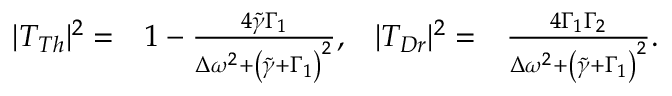Convert formula to latex. <formula><loc_0><loc_0><loc_500><loc_500>\begin{array} { r l r l } { | T _ { T h } | ^ { 2 } = } & { 1 - \frac { 4 \tilde { \gamma } \Gamma _ { 1 } } { \Delta \omega ^ { 2 } + \left ( \tilde { \gamma } + \Gamma _ { 1 } \right ) ^ { 2 } } , } & { | T _ { D r } | ^ { 2 } = } & { \frac { 4 \Gamma _ { 1 } \Gamma _ { 2 } } { \Delta \omega ^ { 2 } + \left ( \tilde { \gamma } + \Gamma _ { 1 } \right ) ^ { 2 } } . } \end{array}</formula> 